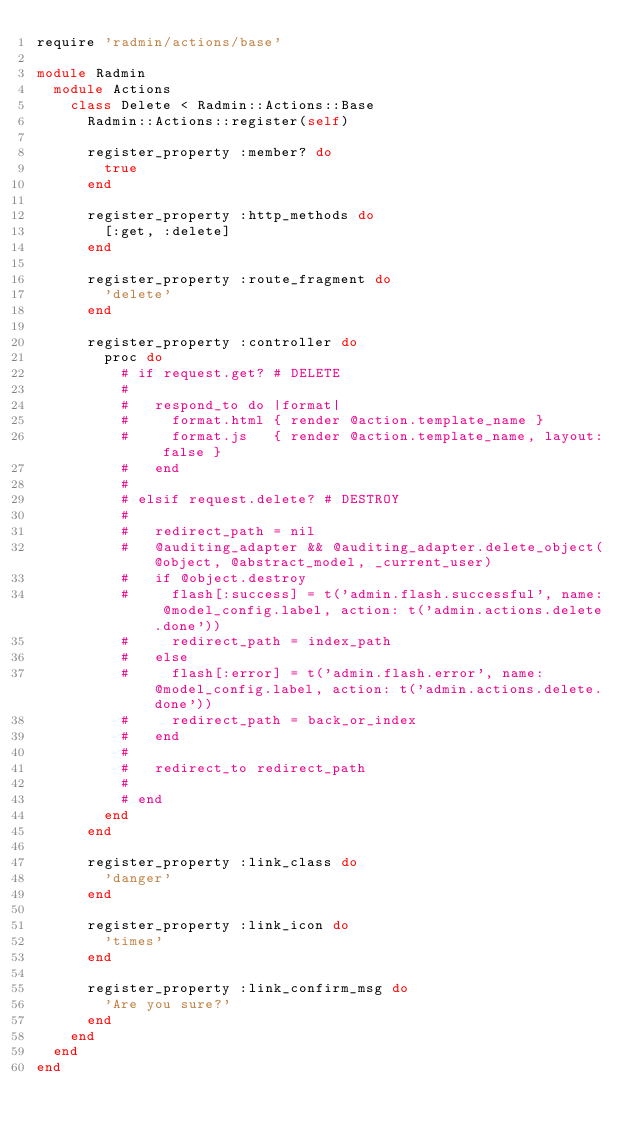<code> <loc_0><loc_0><loc_500><loc_500><_Ruby_>require 'radmin/actions/base'

module Radmin
  module Actions
    class Delete < Radmin::Actions::Base
      Radmin::Actions::register(self)

      register_property :member? do
        true
      end

      register_property :http_methods do
        [:get, :delete]
      end

      register_property :route_fragment do
        'delete'
      end

      register_property :controller do
        proc do
          # if request.get? # DELETE
          #
          #   respond_to do |format|
          #     format.html { render @action.template_name }
          #     format.js   { render @action.template_name, layout: false }
          #   end
          #
          # elsif request.delete? # DESTROY
          #
          #   redirect_path = nil
          #   @auditing_adapter && @auditing_adapter.delete_object(@object, @abstract_model, _current_user)
          #   if @object.destroy
          #     flash[:success] = t('admin.flash.successful', name: @model_config.label, action: t('admin.actions.delete.done'))
          #     redirect_path = index_path
          #   else
          #     flash[:error] = t('admin.flash.error', name: @model_config.label, action: t('admin.actions.delete.done'))
          #     redirect_path = back_or_index
          #   end
          #
          #   redirect_to redirect_path
          #
          # end
        end
      end

      register_property :link_class do
        'danger'
      end

      register_property :link_icon do
        'times'
      end

      register_property :link_confirm_msg do
        'Are you sure?'
      end
    end
  end
end</code> 